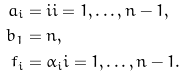<formula> <loc_0><loc_0><loc_500><loc_500>a _ { i } & = i i = 1 , \dots , n - 1 , \\ b _ { 1 } & = n , \\ f _ { i } & = \alpha _ { i } i = 1 , \dots , n - 1 .</formula> 